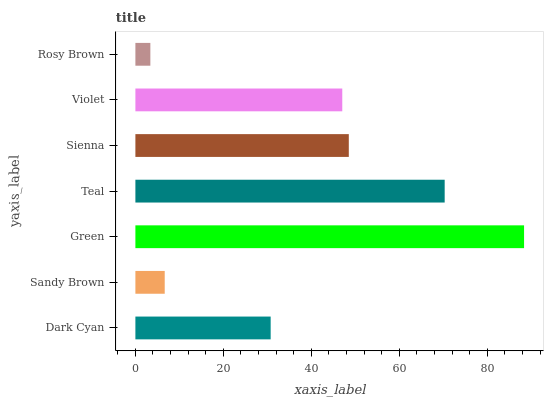Is Rosy Brown the minimum?
Answer yes or no. Yes. Is Green the maximum?
Answer yes or no. Yes. Is Sandy Brown the minimum?
Answer yes or no. No. Is Sandy Brown the maximum?
Answer yes or no. No. Is Dark Cyan greater than Sandy Brown?
Answer yes or no. Yes. Is Sandy Brown less than Dark Cyan?
Answer yes or no. Yes. Is Sandy Brown greater than Dark Cyan?
Answer yes or no. No. Is Dark Cyan less than Sandy Brown?
Answer yes or no. No. Is Violet the high median?
Answer yes or no. Yes. Is Violet the low median?
Answer yes or no. Yes. Is Green the high median?
Answer yes or no. No. Is Dark Cyan the low median?
Answer yes or no. No. 